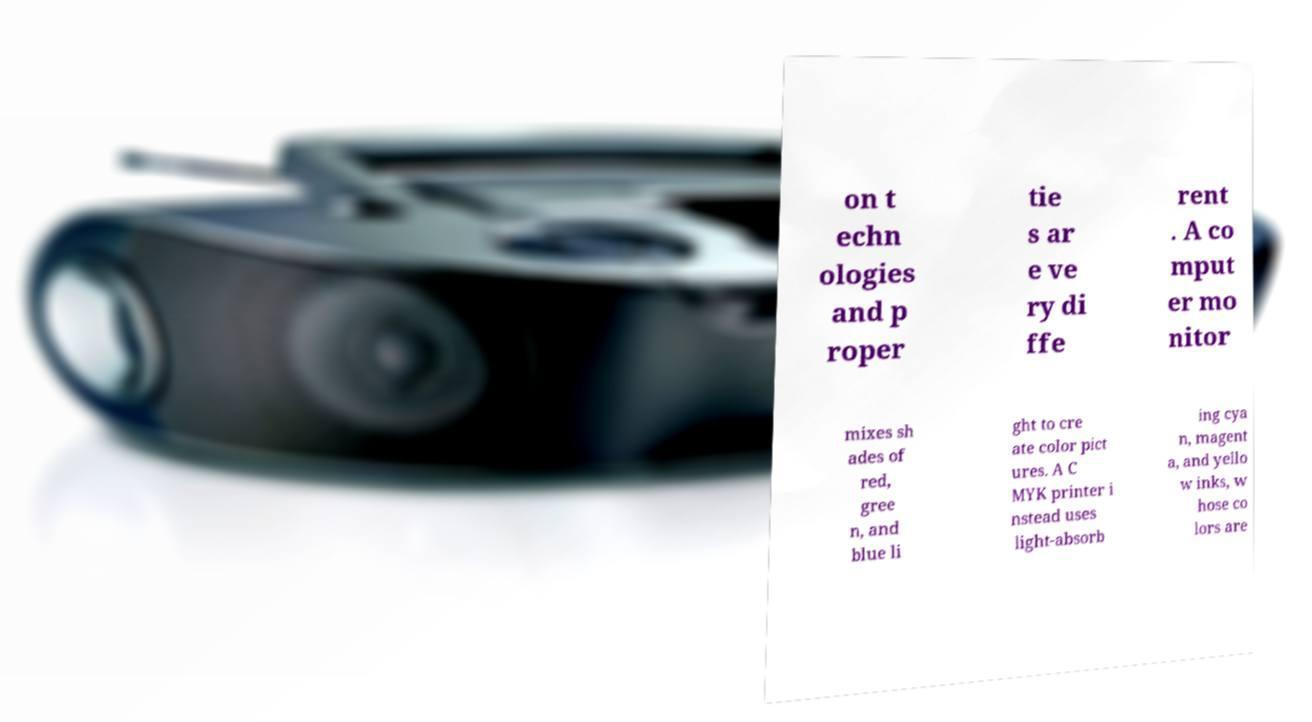Please identify and transcribe the text found in this image. on t echn ologies and p roper tie s ar e ve ry di ffe rent . A co mput er mo nitor mixes sh ades of red, gree n, and blue li ght to cre ate color pict ures. A C MYK printer i nstead uses light-absorb ing cya n, magent a, and yello w inks, w hose co lors are 